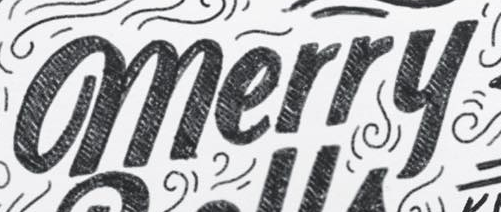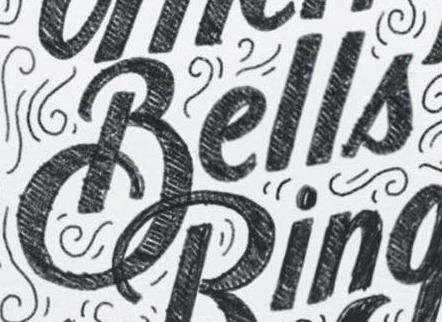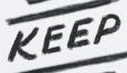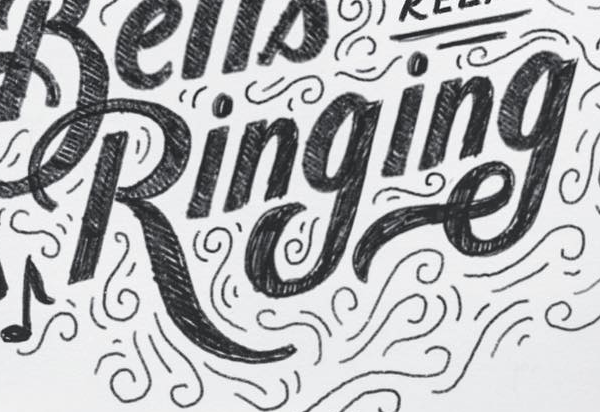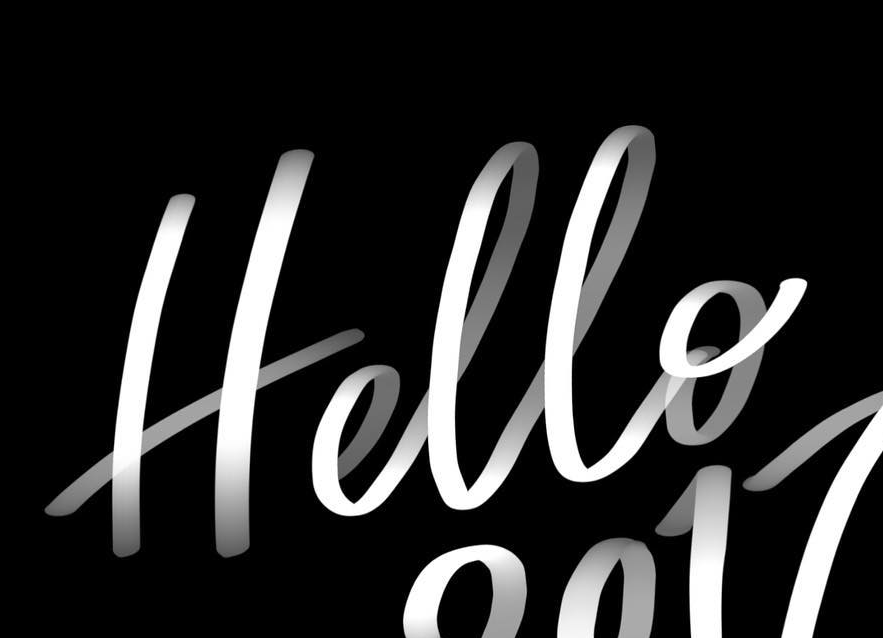Read the text from these images in sequence, separated by a semicolon. merry; Bells; KEEP; Ringing; Hello 